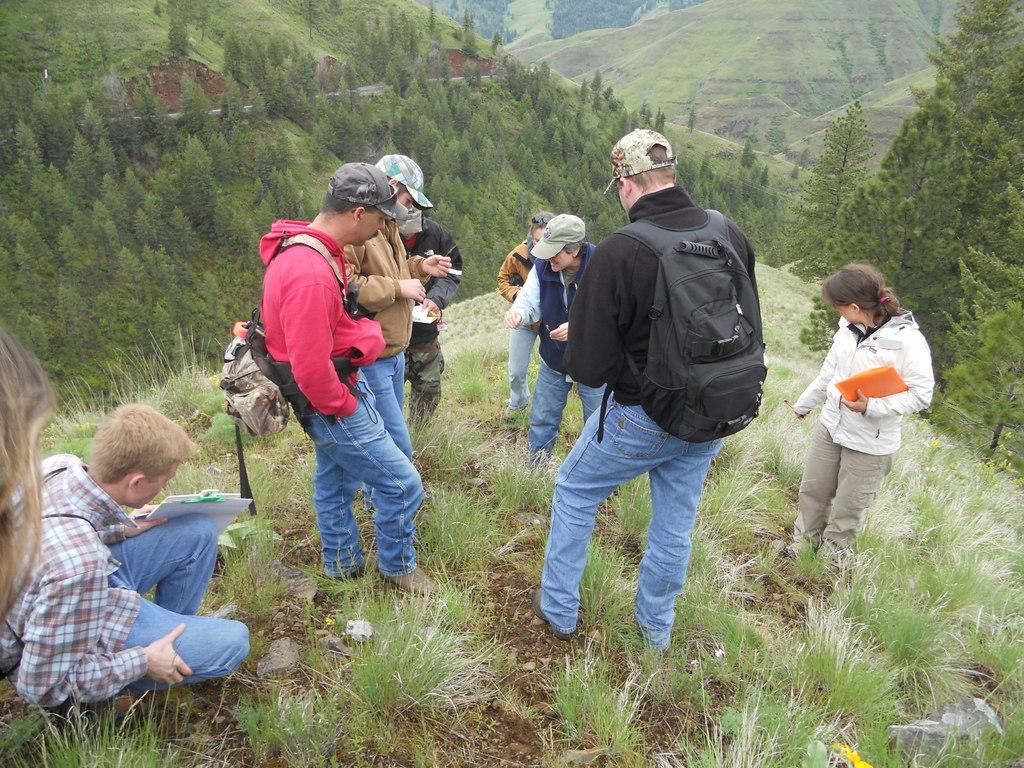What is the main subject of the image? The main subject of the image is a group of people standing. Can you describe the position of one of the people in the image? Yes, there is a person in a squat position in the image. What type of natural environment is visible in the image? Trees, hills, and grass are visible in the image. What type of sack is being exchanged between the people in the image? There is no sack present in the image, and no exchange is taking place between the people. What type of coal can be seen in the image? There is no coal present in the image. 